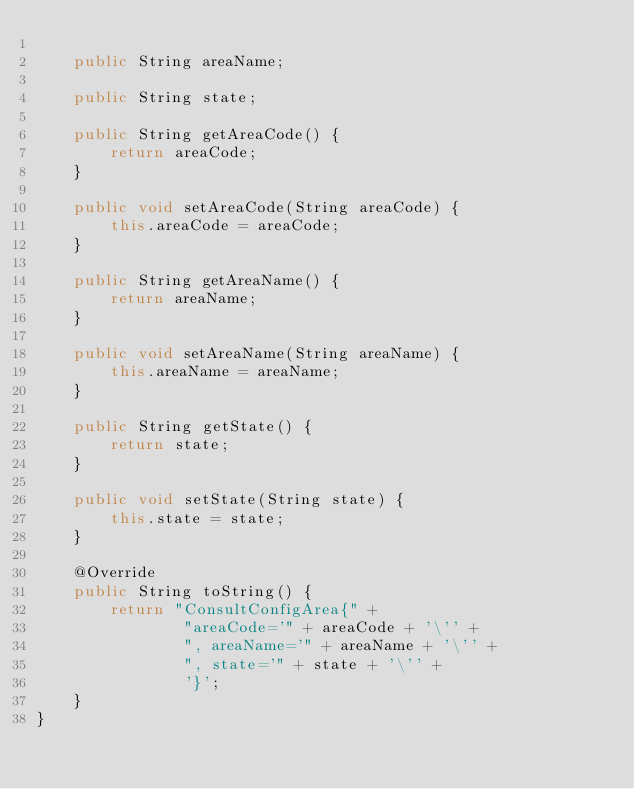Convert code to text. <code><loc_0><loc_0><loc_500><loc_500><_Java_>
    public String areaName;

    public String state;

    public String getAreaCode() {
        return areaCode;
    }

    public void setAreaCode(String areaCode) {
        this.areaCode = areaCode;
    }

    public String getAreaName() {
        return areaName;
    }

    public void setAreaName(String areaName) {
        this.areaName = areaName;
    }

    public String getState() {
        return state;
    }

    public void setState(String state) {
        this.state = state;
    }

    @Override
    public String toString() {
        return "ConsultConfigArea{" +
                "areaCode='" + areaCode + '\'' +
                ", areaName='" + areaName + '\'' +
                ", state='" + state + '\'' +
                '}';
    }
}
</code> 